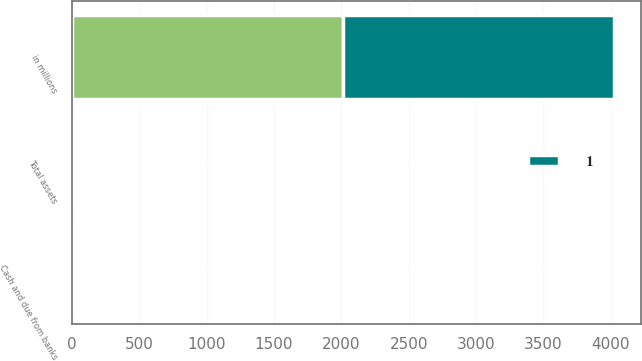<chart> <loc_0><loc_0><loc_500><loc_500><stacked_bar_chart><ecel><fcel>in millions<fcel>Cash and due from banks<fcel>Total assets<nl><fcel>nan<fcel>2013<fcel>20<fcel>20<nl><fcel>1<fcel>2012<fcel>22<fcel>22<nl></chart> 